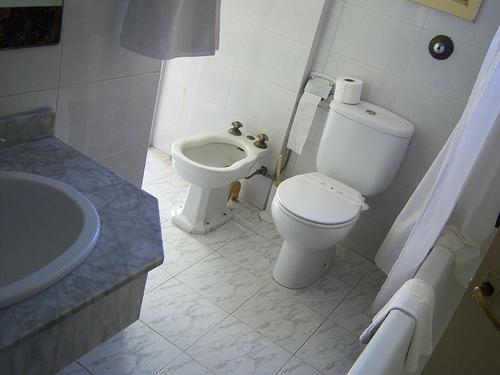Why is the toilet paper on top of the toilet? Please explain your reasoning. easy access. The paper is for easy access. 